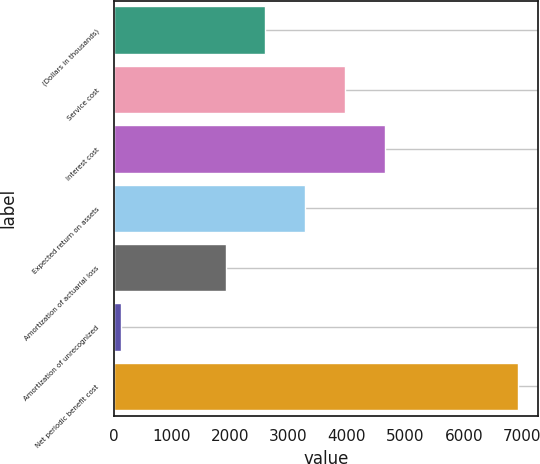Convert chart. <chart><loc_0><loc_0><loc_500><loc_500><bar_chart><fcel>(Dollars in thousands)<fcel>Service cost<fcel>Interest cost<fcel>Expected return on assets<fcel>Amortization of actuarial loss<fcel>Amortization of unrecognized<fcel>Net periodic benefit cost<nl><fcel>2603<fcel>3963<fcel>4643<fcel>3283<fcel>1923<fcel>127<fcel>6927<nl></chart> 